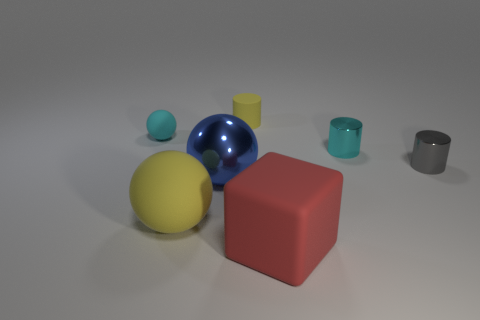Add 2 gray shiny things. How many objects exist? 9 Subtract all balls. How many objects are left? 4 Subtract 0 green cubes. How many objects are left? 7 Subtract all metallic objects. Subtract all big yellow spheres. How many objects are left? 3 Add 4 big things. How many big things are left? 7 Add 7 red cubes. How many red cubes exist? 8 